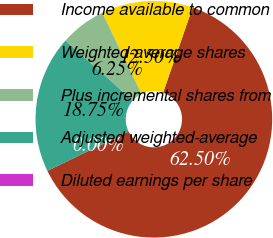Convert chart to OTSL. <chart><loc_0><loc_0><loc_500><loc_500><pie_chart><fcel>Income available to common<fcel>Weighted-average shares<fcel>Plus incremental shares from<fcel>Adjusted weighted-average<fcel>Diluted earnings per share<nl><fcel>62.5%<fcel>12.5%<fcel>6.25%<fcel>18.75%<fcel>0.0%<nl></chart> 